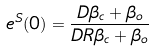Convert formula to latex. <formula><loc_0><loc_0><loc_500><loc_500>e ^ { S } ( 0 ) = \frac { D \beta _ { c } + \beta _ { o } } { D R \beta _ { c } + \beta _ { o } }</formula> 